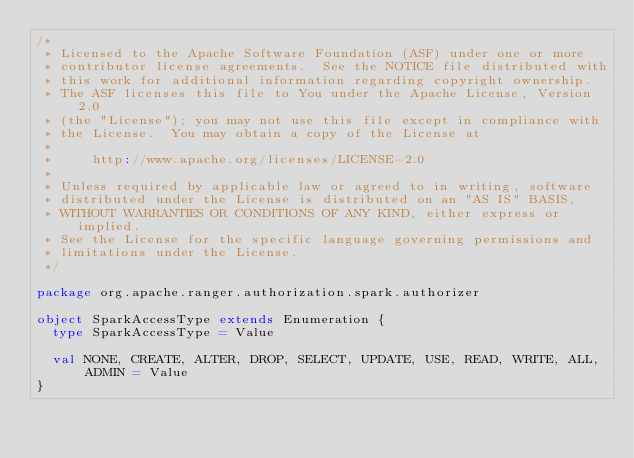<code> <loc_0><loc_0><loc_500><loc_500><_Scala_>/*
 * Licensed to the Apache Software Foundation (ASF) under one or more
 * contributor license agreements.  See the NOTICE file distributed with
 * this work for additional information regarding copyright ownership.
 * The ASF licenses this file to You under the Apache License, Version 2.0
 * (the "License"); you may not use this file except in compliance with
 * the License.  You may obtain a copy of the License at
 *
 *     http://www.apache.org/licenses/LICENSE-2.0
 *
 * Unless required by applicable law or agreed to in writing, software
 * distributed under the License is distributed on an "AS IS" BASIS,
 * WITHOUT WARRANTIES OR CONDITIONS OF ANY KIND, either express or implied.
 * See the License for the specific language governing permissions and
 * limitations under the License.
 */

package org.apache.ranger.authorization.spark.authorizer

object SparkAccessType extends Enumeration {
  type SparkAccessType = Value

  val NONE, CREATE, ALTER, DROP, SELECT, UPDATE, USE, READ, WRITE, ALL, ADMIN = Value
}

</code> 